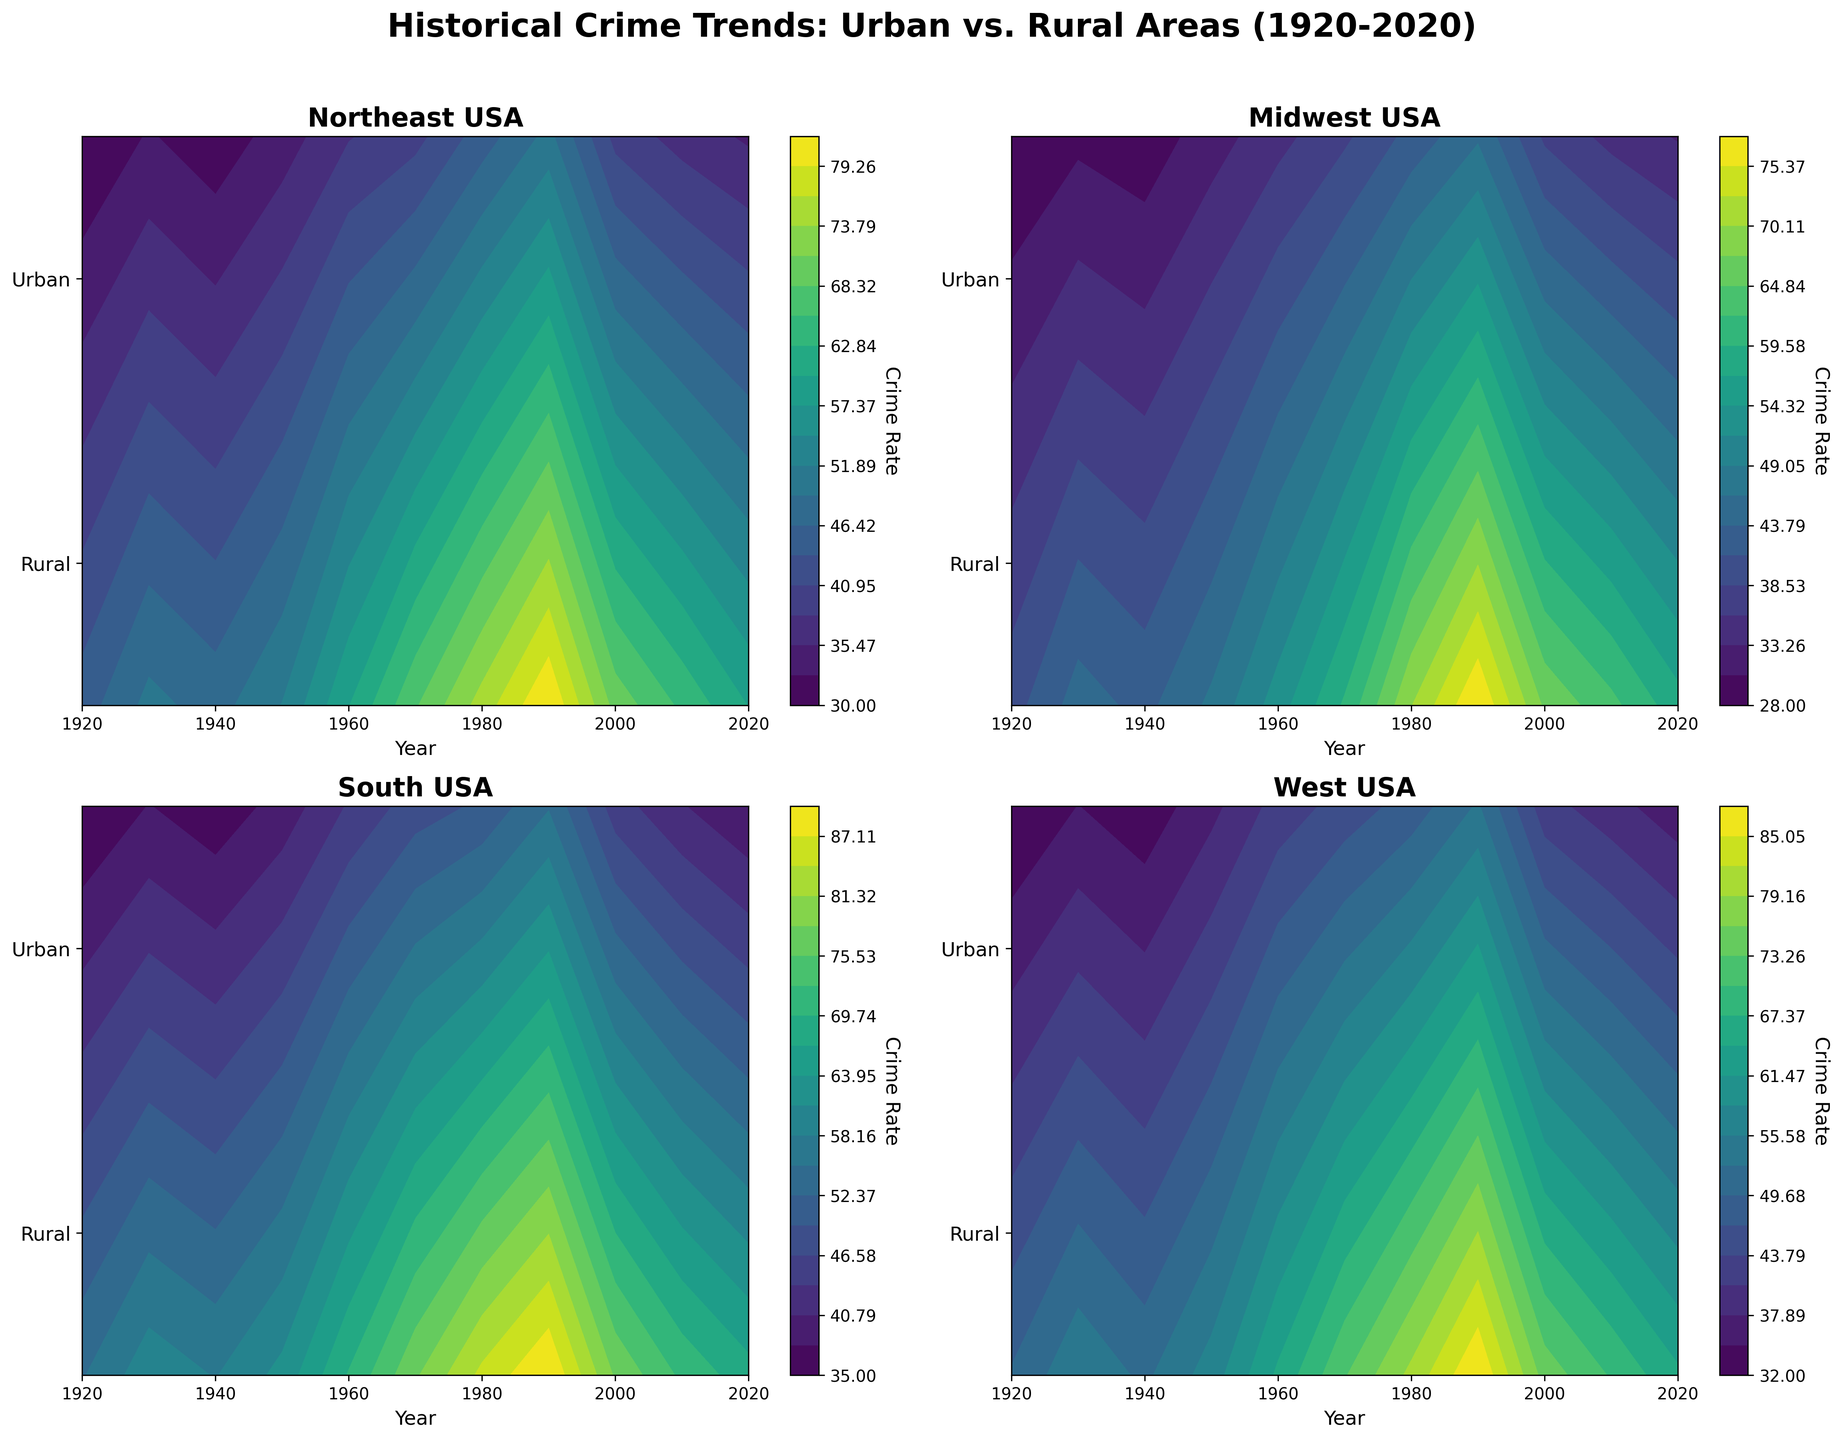What's the title of the figure? The title is located at the top of the figure and summarizes the main topic it covers. Simply reading the title from the figure provides the answer.
Answer: Historical Crime Trends: Urban vs. Rural Areas (1920-2020) How are the years represented on the plots? The years are represented along the x-axis of each subplot, which is labeled "Year." Observing the x-axes of all plots confirms this.
Answer: X-axis Which region's urban crime rate was the highest in 1980? Look at the level sets in the contour plots for 1980 and compare the values for urban crime rates (top half of each subplot). The West USA region has the highest urban crime rate in 1980.
Answer: West USA Between 1920 and 2020, which region shows the largest increase in rural crime rate? To determine the increase, subtract the rural crime rate of 1920 from that of 2020 for each region and compare the differences. The South USA region shows the largest increase in rural crime rate.
Answer: South USA In 1960, which area (urban or rural) had a higher crime rate in the Midwest USA? Check the contour levels for the Midwest USA subplot in 1960. The urban crime rate is higher than the rural crime rate.
Answer: Urban How do the urban crime rates in the Northeast USA compare between 1960 and 2020? Observe the contour levels for the Northeast USA subplot for these years. The urban crime rate decreased from 60 in 1960 to 60 in 2020.
Answer: Decreased What's the average crime rate difference between urban and rural areas across all regions in 1970? Calculate the differences between urban and rural crime rates for each region in 1970, then find the average. Urban rates in Northeast (68) - Rural rates in Northeast (40) + Urban rates in Midwest (60) - Rural rates in Midwest (38) + Urban rates in South (78) - Rural rates in South (48) + Urban rates in West (73) - Rural rates in West (45) = 28 + 22 + 30 + 28 = 108. Divide by 4 (number of regions).
Answer: 27 Which region had the smallest gap between urban and rural crime rates in 2000? Compare the gaps between urban and rural crime rates for each region in 2000. The Midwest USA had the smallest gap between urban (67) and rural (38) crime rates.
Answer: Midwest USA From which decade did the South USA start having urban crime rates consistently in the 70s or higher? Inspect the contour plot for the South USA and identify the first decade where urban crime rates are consistently 70 or higher. This trend starts in the 1960s.
Answer: 1960s By 2020, what noticeable trends can be observed regarding urban and rural crime rates across all regions? Analyze the contours for each region in 2020. Generally, urban crime rates have notably decreased, and rural crime rates have either stabilized or decreased slightly.
Answer: Decreasing urban, stable rural 